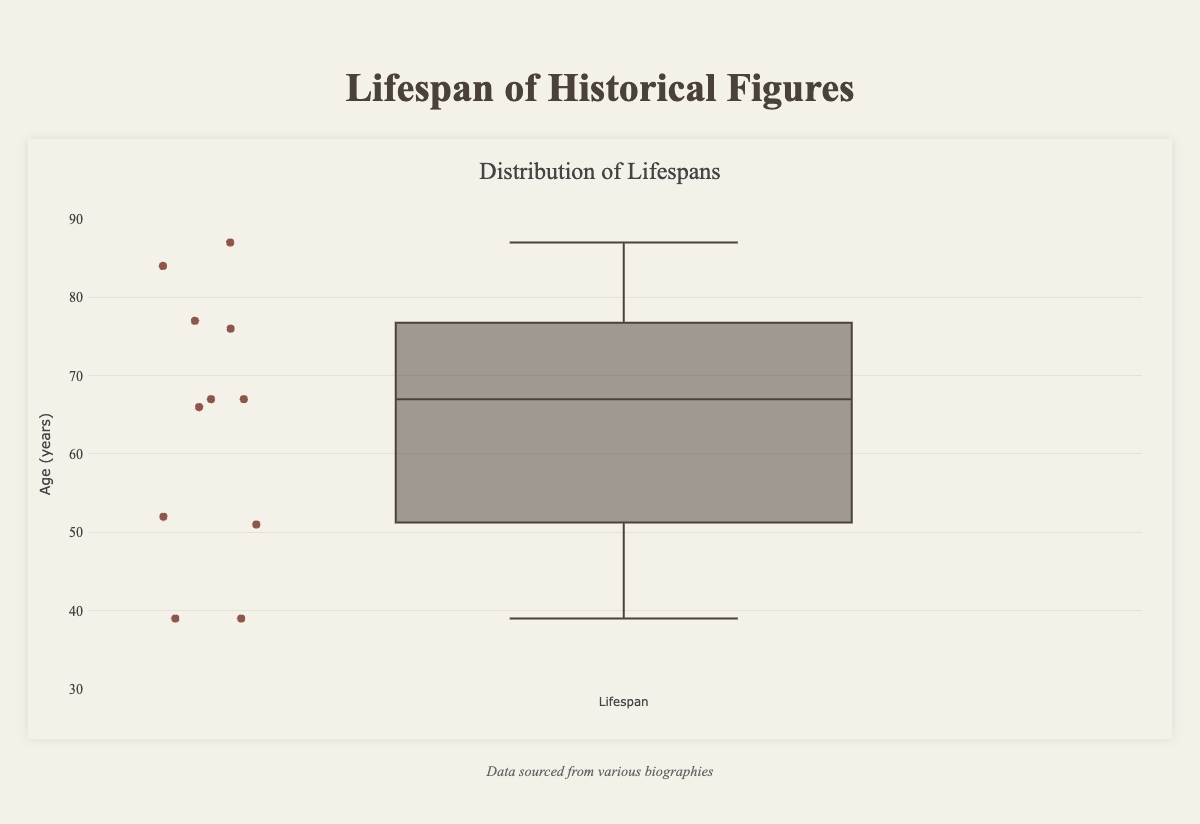What is the title of the box plot? The title of a box plot is typically displayed at the top of the plot. In this case, the title is provided in the structure of the data and code.
Answer: Distribution of Lifespans What is the range of lifespans displayed on the y-axis? The y-axis is marked with a range that encapsulates the values of the data points. This range is explicitly defined in the layout section's y-axis configuration.
Answer: 30 to 90 years How many historical figures are represented in the box plot? The number of historical figures can be counted by identifying each unique data point in the y-array of the data. In this case, there are 11 entries in the list provided.
Answer: 11 Which historical figure has the highest recorded lifespan in this plot? By examining the individual lifespans and identifying the maximum value, one can determine which historical figure has the longest lifespan. Mother Teresa lived the longest with a lifespan of 87 years.
Answer: Mother Teresa What is the median lifespan of the historical figures on the box plot? The median lifespan is the middle value of the ordered dataset when the number of values (11) is odd. Sorting the lifespans in ascending order and selecting the middle value gives us the median. The sorted lifespans are (39, 39, 51, 52, 66, 67, 67, 76, 77, 84, 87). The median value is the 6th value.
Answer: 67 What was the lifespan of the youngest historical figures on this plot? By examining the sorted list of lifespans, we can identify the minimum value. Both Cleopatra and Martin Luther King Jr. have the minimum lifespan, which is 39 years.
Answer: 39 years How many figures lived 70 years or longer? To determine this, count the number of lifespans that equal or exceed 70 from the array: 84, 76, 77, and 87.
Answer: 4 figures What is the interquartile range (IQR) of the lifespans presented in the box plot? The interquartile range (IQR) is calculated as the difference between the 75th percentile (Q3) and the 25th percentile (Q1). For the sorted lifespans (39, 39, 51, 52, 66, 67, 67, 76, 77, 84, 87), Q1 is the 3rd value (51) and Q3 is the 9th value (76). The IQR is Q3 - Q1.
Answer: 25 years How does the lifespan of Isaac Newton compare to the median lifespan? Isaac Newton's lifespan can be found in the list (84 years), and the median lifespan, as calculated above, is 67. Isaac Newton's lifespan is greater than the median lifespan.
Answer: Greater Between Albert Einstein and Galileo Galilei, who had a longer lifespan? Reviewing their respective lifespans listed as 76 for Albert Einstein and 77 for Galileo Galilei, Galileo lived 1 year longer than Einstein.
Answer: Galileo Galilei 